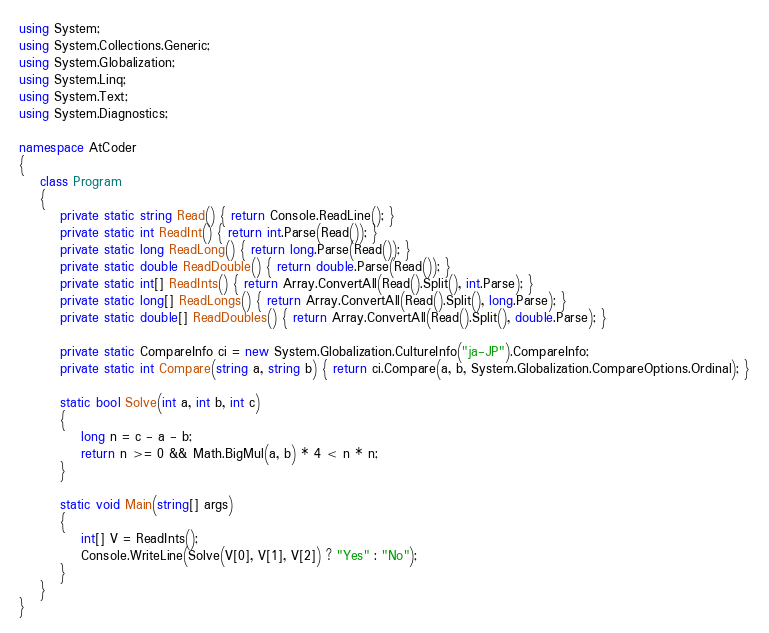<code> <loc_0><loc_0><loc_500><loc_500><_C#_>using System;
using System.Collections.Generic;
using System.Globalization;
using System.Linq;
using System.Text;
using System.Diagnostics;

namespace AtCoder
{
    class Program
    {
        private static string Read() { return Console.ReadLine(); }
        private static int ReadInt() { return int.Parse(Read()); }
        private static long ReadLong() { return long.Parse(Read()); }
        private static double ReadDouble() { return double.Parse(Read()); }
        private static int[] ReadInts() { return Array.ConvertAll(Read().Split(), int.Parse); }
        private static long[] ReadLongs() { return Array.ConvertAll(Read().Split(), long.Parse); }
        private static double[] ReadDoubles() { return Array.ConvertAll(Read().Split(), double.Parse); }

        private static CompareInfo ci = new System.Globalization.CultureInfo("ja-JP").CompareInfo;
        private static int Compare(string a, string b) { return ci.Compare(a, b, System.Globalization.CompareOptions.Ordinal); }

        static bool Solve(int a, int b, int c)
        {
            long n = c - a - b;
            return n >= 0 && Math.BigMul(a, b) * 4 < n * n;
        }

        static void Main(string[] args)
        {
            int[] V = ReadInts();
            Console.WriteLine(Solve(V[0], V[1], V[2]) ? "Yes" : "No");
        }
    }
}
</code> 